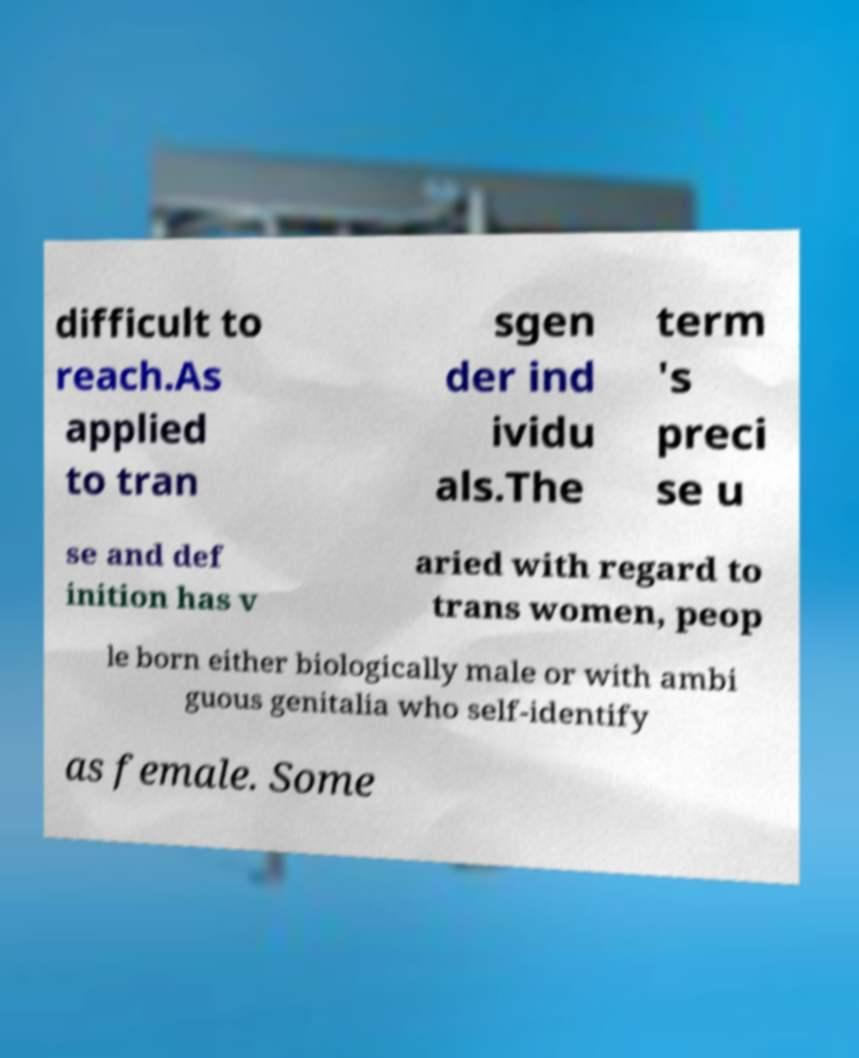What messages or text are displayed in this image? I need them in a readable, typed format. difficult to reach.As applied to tran sgen der ind ividu als.The term 's preci se u se and def inition has v aried with regard to trans women, peop le born either biologically male or with ambi guous genitalia who self-identify as female. Some 